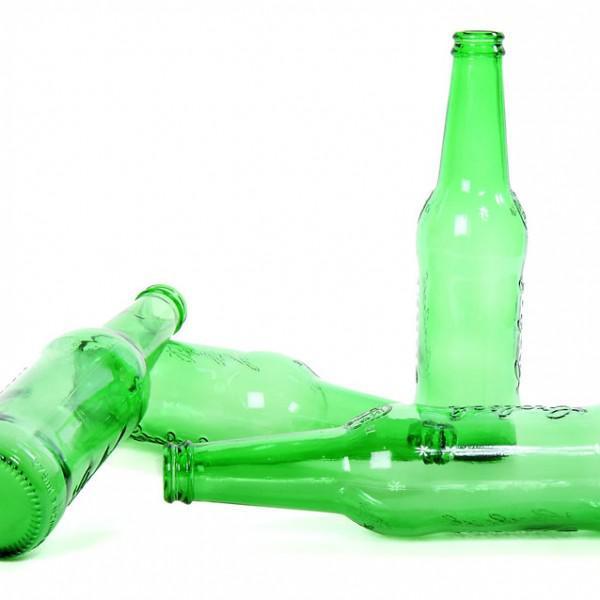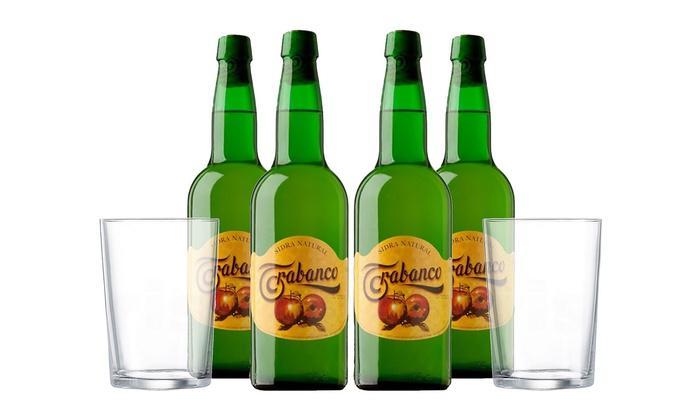The first image is the image on the left, the second image is the image on the right. For the images displayed, is the sentence "One image includes at least one glass containing beer, along with at least one beer bottle." factually correct? Answer yes or no. No. The first image is the image on the left, the second image is the image on the right. Assess this claim about the two images: "In one image, the bottles are capped and have distinctive matching labels, while the other image is of empty, uncapped bottles.". Correct or not? Answer yes or no. Yes. The first image is the image on the left, the second image is the image on the right. For the images displayed, is the sentence "An image includes at least one green bottle displayed horizontally." factually correct? Answer yes or no. Yes. The first image is the image on the left, the second image is the image on the right. For the images displayed, is the sentence "There are four green bottles in the left image." factually correct? Answer yes or no. Yes. 